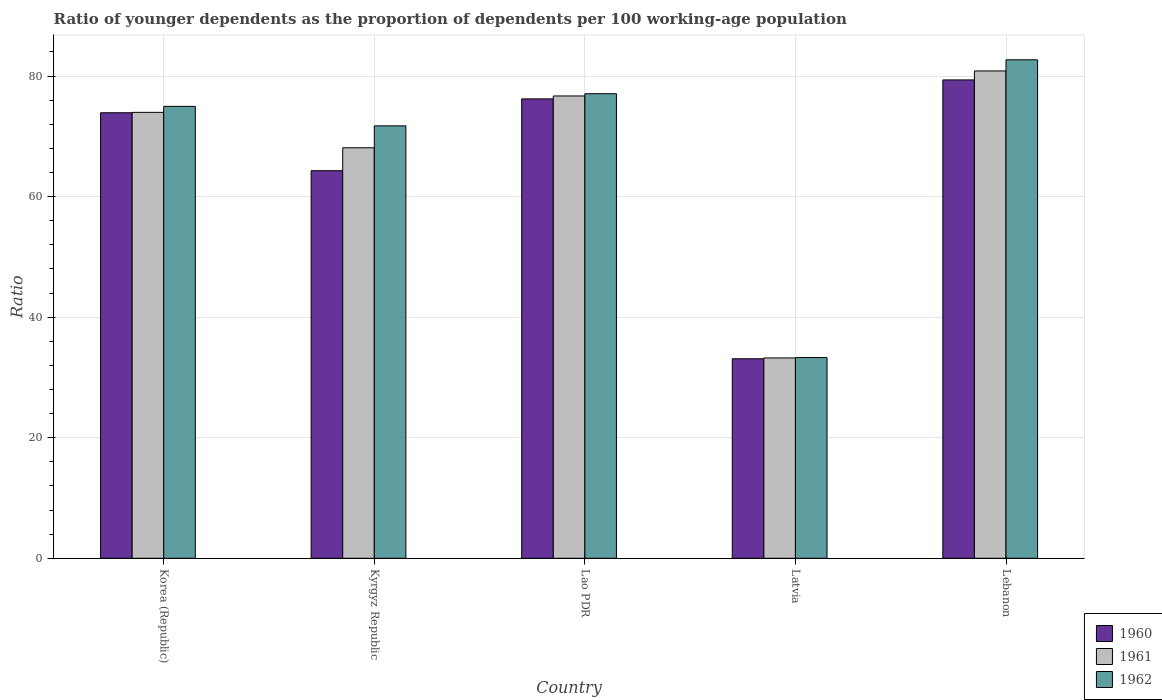Are the number of bars per tick equal to the number of legend labels?
Make the answer very short. Yes. How many bars are there on the 1st tick from the left?
Make the answer very short. 3. How many bars are there on the 3rd tick from the right?
Give a very brief answer. 3. What is the label of the 3rd group of bars from the left?
Provide a short and direct response. Lao PDR. What is the age dependency ratio(young) in 1962 in Kyrgyz Republic?
Your answer should be very brief. 71.73. Across all countries, what is the maximum age dependency ratio(young) in 1961?
Give a very brief answer. 80.84. Across all countries, what is the minimum age dependency ratio(young) in 1961?
Make the answer very short. 33.23. In which country was the age dependency ratio(young) in 1962 maximum?
Your answer should be very brief. Lebanon. In which country was the age dependency ratio(young) in 1962 minimum?
Give a very brief answer. Latvia. What is the total age dependency ratio(young) in 1962 in the graph?
Make the answer very short. 339.74. What is the difference between the age dependency ratio(young) in 1960 in Korea (Republic) and that in Latvia?
Give a very brief answer. 40.81. What is the difference between the age dependency ratio(young) in 1960 in Latvia and the age dependency ratio(young) in 1962 in Kyrgyz Republic?
Your response must be concise. -38.64. What is the average age dependency ratio(young) in 1961 per country?
Provide a succinct answer. 66.56. What is the difference between the age dependency ratio(young) of/in 1961 and age dependency ratio(young) of/in 1962 in Lao PDR?
Your response must be concise. -0.37. In how many countries, is the age dependency ratio(young) in 1962 greater than 60?
Offer a terse response. 4. What is the ratio of the age dependency ratio(young) in 1961 in Latvia to that in Lebanon?
Keep it short and to the point. 0.41. Is the age dependency ratio(young) in 1962 in Korea (Republic) less than that in Lao PDR?
Ensure brevity in your answer.  Yes. Is the difference between the age dependency ratio(young) in 1961 in Kyrgyz Republic and Latvia greater than the difference between the age dependency ratio(young) in 1962 in Kyrgyz Republic and Latvia?
Give a very brief answer. No. What is the difference between the highest and the second highest age dependency ratio(young) in 1960?
Your answer should be very brief. -2.3. What is the difference between the highest and the lowest age dependency ratio(young) in 1962?
Provide a succinct answer. 49.39. Is the sum of the age dependency ratio(young) in 1960 in Kyrgyz Republic and Latvia greater than the maximum age dependency ratio(young) in 1961 across all countries?
Ensure brevity in your answer.  Yes. What does the 2nd bar from the left in Lebanon represents?
Provide a succinct answer. 1961. What does the 3rd bar from the right in Kyrgyz Republic represents?
Ensure brevity in your answer.  1960. How many countries are there in the graph?
Ensure brevity in your answer.  5. What is the difference between two consecutive major ticks on the Y-axis?
Make the answer very short. 20. Are the values on the major ticks of Y-axis written in scientific E-notation?
Your response must be concise. No. Does the graph contain grids?
Keep it short and to the point. Yes. Where does the legend appear in the graph?
Provide a succinct answer. Bottom right. How many legend labels are there?
Your answer should be very brief. 3. How are the legend labels stacked?
Give a very brief answer. Vertical. What is the title of the graph?
Provide a short and direct response. Ratio of younger dependents as the proportion of dependents per 100 working-age population. What is the label or title of the Y-axis?
Give a very brief answer. Ratio. What is the Ratio in 1960 in Korea (Republic)?
Your answer should be very brief. 73.91. What is the Ratio in 1961 in Korea (Republic)?
Keep it short and to the point. 73.97. What is the Ratio in 1962 in Korea (Republic)?
Keep it short and to the point. 74.96. What is the Ratio in 1960 in Kyrgyz Republic?
Give a very brief answer. 64.29. What is the Ratio of 1961 in Kyrgyz Republic?
Your response must be concise. 68.1. What is the Ratio in 1962 in Kyrgyz Republic?
Make the answer very short. 71.73. What is the Ratio in 1960 in Lao PDR?
Make the answer very short. 76.2. What is the Ratio in 1961 in Lao PDR?
Ensure brevity in your answer.  76.69. What is the Ratio of 1962 in Lao PDR?
Keep it short and to the point. 77.06. What is the Ratio of 1960 in Latvia?
Give a very brief answer. 33.09. What is the Ratio of 1961 in Latvia?
Your response must be concise. 33.23. What is the Ratio in 1962 in Latvia?
Make the answer very short. 33.3. What is the Ratio of 1960 in Lebanon?
Provide a succinct answer. 79.35. What is the Ratio of 1961 in Lebanon?
Your answer should be very brief. 80.84. What is the Ratio of 1962 in Lebanon?
Make the answer very short. 82.69. Across all countries, what is the maximum Ratio in 1960?
Offer a terse response. 79.35. Across all countries, what is the maximum Ratio of 1961?
Your answer should be compact. 80.84. Across all countries, what is the maximum Ratio in 1962?
Offer a terse response. 82.69. Across all countries, what is the minimum Ratio in 1960?
Give a very brief answer. 33.09. Across all countries, what is the minimum Ratio of 1961?
Give a very brief answer. 33.23. Across all countries, what is the minimum Ratio in 1962?
Keep it short and to the point. 33.3. What is the total Ratio in 1960 in the graph?
Your answer should be compact. 326.85. What is the total Ratio of 1961 in the graph?
Your answer should be compact. 332.82. What is the total Ratio of 1962 in the graph?
Ensure brevity in your answer.  339.74. What is the difference between the Ratio in 1960 in Korea (Republic) and that in Kyrgyz Republic?
Offer a very short reply. 9.61. What is the difference between the Ratio in 1961 in Korea (Republic) and that in Kyrgyz Republic?
Provide a succinct answer. 5.87. What is the difference between the Ratio in 1962 in Korea (Republic) and that in Kyrgyz Republic?
Make the answer very short. 3.23. What is the difference between the Ratio of 1960 in Korea (Republic) and that in Lao PDR?
Make the answer very short. -2.3. What is the difference between the Ratio in 1961 in Korea (Republic) and that in Lao PDR?
Your response must be concise. -2.72. What is the difference between the Ratio in 1962 in Korea (Republic) and that in Lao PDR?
Keep it short and to the point. -2.1. What is the difference between the Ratio in 1960 in Korea (Republic) and that in Latvia?
Your response must be concise. 40.81. What is the difference between the Ratio of 1961 in Korea (Republic) and that in Latvia?
Give a very brief answer. 40.74. What is the difference between the Ratio of 1962 in Korea (Republic) and that in Latvia?
Your response must be concise. 41.66. What is the difference between the Ratio of 1960 in Korea (Republic) and that in Lebanon?
Your answer should be very brief. -5.45. What is the difference between the Ratio in 1961 in Korea (Republic) and that in Lebanon?
Your response must be concise. -6.87. What is the difference between the Ratio in 1962 in Korea (Republic) and that in Lebanon?
Ensure brevity in your answer.  -7.73. What is the difference between the Ratio in 1960 in Kyrgyz Republic and that in Lao PDR?
Your answer should be very brief. -11.91. What is the difference between the Ratio of 1961 in Kyrgyz Republic and that in Lao PDR?
Your answer should be compact. -8.59. What is the difference between the Ratio of 1962 in Kyrgyz Republic and that in Lao PDR?
Keep it short and to the point. -5.33. What is the difference between the Ratio of 1960 in Kyrgyz Republic and that in Latvia?
Give a very brief answer. 31.2. What is the difference between the Ratio in 1961 in Kyrgyz Republic and that in Latvia?
Provide a short and direct response. 34.87. What is the difference between the Ratio in 1962 in Kyrgyz Republic and that in Latvia?
Make the answer very short. 38.43. What is the difference between the Ratio of 1960 in Kyrgyz Republic and that in Lebanon?
Your response must be concise. -15.06. What is the difference between the Ratio of 1961 in Kyrgyz Republic and that in Lebanon?
Keep it short and to the point. -12.74. What is the difference between the Ratio of 1962 in Kyrgyz Republic and that in Lebanon?
Ensure brevity in your answer.  -10.96. What is the difference between the Ratio of 1960 in Lao PDR and that in Latvia?
Keep it short and to the point. 43.11. What is the difference between the Ratio in 1961 in Lao PDR and that in Latvia?
Keep it short and to the point. 43.46. What is the difference between the Ratio in 1962 in Lao PDR and that in Latvia?
Offer a very short reply. 43.76. What is the difference between the Ratio of 1960 in Lao PDR and that in Lebanon?
Keep it short and to the point. -3.15. What is the difference between the Ratio of 1961 in Lao PDR and that in Lebanon?
Your response must be concise. -4.15. What is the difference between the Ratio in 1962 in Lao PDR and that in Lebanon?
Give a very brief answer. -5.63. What is the difference between the Ratio in 1960 in Latvia and that in Lebanon?
Your answer should be very brief. -46.26. What is the difference between the Ratio of 1961 in Latvia and that in Lebanon?
Provide a short and direct response. -47.61. What is the difference between the Ratio in 1962 in Latvia and that in Lebanon?
Offer a very short reply. -49.39. What is the difference between the Ratio of 1960 in Korea (Republic) and the Ratio of 1961 in Kyrgyz Republic?
Your response must be concise. 5.81. What is the difference between the Ratio of 1960 in Korea (Republic) and the Ratio of 1962 in Kyrgyz Republic?
Your response must be concise. 2.17. What is the difference between the Ratio in 1961 in Korea (Republic) and the Ratio in 1962 in Kyrgyz Republic?
Make the answer very short. 2.24. What is the difference between the Ratio in 1960 in Korea (Republic) and the Ratio in 1961 in Lao PDR?
Provide a succinct answer. -2.78. What is the difference between the Ratio in 1960 in Korea (Republic) and the Ratio in 1962 in Lao PDR?
Keep it short and to the point. -3.16. What is the difference between the Ratio in 1961 in Korea (Republic) and the Ratio in 1962 in Lao PDR?
Make the answer very short. -3.09. What is the difference between the Ratio in 1960 in Korea (Republic) and the Ratio in 1961 in Latvia?
Offer a very short reply. 40.68. What is the difference between the Ratio of 1960 in Korea (Republic) and the Ratio of 1962 in Latvia?
Offer a terse response. 40.61. What is the difference between the Ratio in 1961 in Korea (Republic) and the Ratio in 1962 in Latvia?
Keep it short and to the point. 40.67. What is the difference between the Ratio of 1960 in Korea (Republic) and the Ratio of 1961 in Lebanon?
Your answer should be compact. -6.93. What is the difference between the Ratio in 1960 in Korea (Republic) and the Ratio in 1962 in Lebanon?
Offer a terse response. -8.78. What is the difference between the Ratio of 1961 in Korea (Republic) and the Ratio of 1962 in Lebanon?
Your answer should be very brief. -8.72. What is the difference between the Ratio of 1960 in Kyrgyz Republic and the Ratio of 1961 in Lao PDR?
Keep it short and to the point. -12.4. What is the difference between the Ratio of 1960 in Kyrgyz Republic and the Ratio of 1962 in Lao PDR?
Your answer should be compact. -12.77. What is the difference between the Ratio of 1961 in Kyrgyz Republic and the Ratio of 1962 in Lao PDR?
Provide a short and direct response. -8.97. What is the difference between the Ratio of 1960 in Kyrgyz Republic and the Ratio of 1961 in Latvia?
Make the answer very short. 31.06. What is the difference between the Ratio of 1960 in Kyrgyz Republic and the Ratio of 1962 in Latvia?
Provide a short and direct response. 30.99. What is the difference between the Ratio of 1961 in Kyrgyz Republic and the Ratio of 1962 in Latvia?
Your answer should be very brief. 34.8. What is the difference between the Ratio in 1960 in Kyrgyz Republic and the Ratio in 1961 in Lebanon?
Your answer should be compact. -16.55. What is the difference between the Ratio of 1960 in Kyrgyz Republic and the Ratio of 1962 in Lebanon?
Give a very brief answer. -18.4. What is the difference between the Ratio of 1961 in Kyrgyz Republic and the Ratio of 1962 in Lebanon?
Your answer should be very brief. -14.59. What is the difference between the Ratio in 1960 in Lao PDR and the Ratio in 1961 in Latvia?
Your answer should be very brief. 42.97. What is the difference between the Ratio in 1960 in Lao PDR and the Ratio in 1962 in Latvia?
Ensure brevity in your answer.  42.91. What is the difference between the Ratio in 1961 in Lao PDR and the Ratio in 1962 in Latvia?
Offer a terse response. 43.39. What is the difference between the Ratio in 1960 in Lao PDR and the Ratio in 1961 in Lebanon?
Your answer should be compact. -4.63. What is the difference between the Ratio of 1960 in Lao PDR and the Ratio of 1962 in Lebanon?
Provide a succinct answer. -6.48. What is the difference between the Ratio in 1961 in Lao PDR and the Ratio in 1962 in Lebanon?
Give a very brief answer. -6. What is the difference between the Ratio in 1960 in Latvia and the Ratio in 1961 in Lebanon?
Keep it short and to the point. -47.74. What is the difference between the Ratio of 1960 in Latvia and the Ratio of 1962 in Lebanon?
Provide a succinct answer. -49.59. What is the difference between the Ratio of 1961 in Latvia and the Ratio of 1962 in Lebanon?
Ensure brevity in your answer.  -49.46. What is the average Ratio in 1960 per country?
Ensure brevity in your answer.  65.37. What is the average Ratio in 1961 per country?
Make the answer very short. 66.56. What is the average Ratio of 1962 per country?
Provide a short and direct response. 67.95. What is the difference between the Ratio in 1960 and Ratio in 1961 in Korea (Republic)?
Offer a very short reply. -0.06. What is the difference between the Ratio of 1960 and Ratio of 1962 in Korea (Republic)?
Give a very brief answer. -1.05. What is the difference between the Ratio in 1961 and Ratio in 1962 in Korea (Republic)?
Keep it short and to the point. -0.99. What is the difference between the Ratio of 1960 and Ratio of 1961 in Kyrgyz Republic?
Ensure brevity in your answer.  -3.8. What is the difference between the Ratio of 1960 and Ratio of 1962 in Kyrgyz Republic?
Your response must be concise. -7.44. What is the difference between the Ratio in 1961 and Ratio in 1962 in Kyrgyz Republic?
Provide a short and direct response. -3.64. What is the difference between the Ratio in 1960 and Ratio in 1961 in Lao PDR?
Your answer should be compact. -0.48. What is the difference between the Ratio in 1960 and Ratio in 1962 in Lao PDR?
Ensure brevity in your answer.  -0.86. What is the difference between the Ratio in 1961 and Ratio in 1962 in Lao PDR?
Offer a terse response. -0.37. What is the difference between the Ratio in 1960 and Ratio in 1961 in Latvia?
Your response must be concise. -0.13. What is the difference between the Ratio of 1960 and Ratio of 1962 in Latvia?
Your answer should be very brief. -0.2. What is the difference between the Ratio in 1961 and Ratio in 1962 in Latvia?
Offer a very short reply. -0.07. What is the difference between the Ratio of 1960 and Ratio of 1961 in Lebanon?
Offer a very short reply. -1.49. What is the difference between the Ratio in 1960 and Ratio in 1962 in Lebanon?
Offer a very short reply. -3.34. What is the difference between the Ratio of 1961 and Ratio of 1962 in Lebanon?
Offer a terse response. -1.85. What is the ratio of the Ratio of 1960 in Korea (Republic) to that in Kyrgyz Republic?
Your answer should be compact. 1.15. What is the ratio of the Ratio in 1961 in Korea (Republic) to that in Kyrgyz Republic?
Make the answer very short. 1.09. What is the ratio of the Ratio in 1962 in Korea (Republic) to that in Kyrgyz Republic?
Ensure brevity in your answer.  1.04. What is the ratio of the Ratio of 1960 in Korea (Republic) to that in Lao PDR?
Your answer should be compact. 0.97. What is the ratio of the Ratio of 1961 in Korea (Republic) to that in Lao PDR?
Keep it short and to the point. 0.96. What is the ratio of the Ratio in 1962 in Korea (Republic) to that in Lao PDR?
Your answer should be compact. 0.97. What is the ratio of the Ratio in 1960 in Korea (Republic) to that in Latvia?
Your answer should be very brief. 2.23. What is the ratio of the Ratio of 1961 in Korea (Republic) to that in Latvia?
Your answer should be very brief. 2.23. What is the ratio of the Ratio of 1962 in Korea (Republic) to that in Latvia?
Ensure brevity in your answer.  2.25. What is the ratio of the Ratio in 1960 in Korea (Republic) to that in Lebanon?
Your answer should be very brief. 0.93. What is the ratio of the Ratio in 1961 in Korea (Republic) to that in Lebanon?
Your answer should be compact. 0.92. What is the ratio of the Ratio of 1962 in Korea (Republic) to that in Lebanon?
Give a very brief answer. 0.91. What is the ratio of the Ratio of 1960 in Kyrgyz Republic to that in Lao PDR?
Give a very brief answer. 0.84. What is the ratio of the Ratio in 1961 in Kyrgyz Republic to that in Lao PDR?
Ensure brevity in your answer.  0.89. What is the ratio of the Ratio in 1962 in Kyrgyz Republic to that in Lao PDR?
Make the answer very short. 0.93. What is the ratio of the Ratio in 1960 in Kyrgyz Republic to that in Latvia?
Make the answer very short. 1.94. What is the ratio of the Ratio in 1961 in Kyrgyz Republic to that in Latvia?
Your answer should be compact. 2.05. What is the ratio of the Ratio in 1962 in Kyrgyz Republic to that in Latvia?
Your answer should be very brief. 2.15. What is the ratio of the Ratio of 1960 in Kyrgyz Republic to that in Lebanon?
Offer a very short reply. 0.81. What is the ratio of the Ratio in 1961 in Kyrgyz Republic to that in Lebanon?
Keep it short and to the point. 0.84. What is the ratio of the Ratio in 1962 in Kyrgyz Republic to that in Lebanon?
Offer a very short reply. 0.87. What is the ratio of the Ratio in 1960 in Lao PDR to that in Latvia?
Your answer should be compact. 2.3. What is the ratio of the Ratio of 1961 in Lao PDR to that in Latvia?
Your answer should be compact. 2.31. What is the ratio of the Ratio of 1962 in Lao PDR to that in Latvia?
Provide a short and direct response. 2.31. What is the ratio of the Ratio in 1960 in Lao PDR to that in Lebanon?
Provide a short and direct response. 0.96. What is the ratio of the Ratio of 1961 in Lao PDR to that in Lebanon?
Ensure brevity in your answer.  0.95. What is the ratio of the Ratio of 1962 in Lao PDR to that in Lebanon?
Provide a short and direct response. 0.93. What is the ratio of the Ratio in 1960 in Latvia to that in Lebanon?
Ensure brevity in your answer.  0.42. What is the ratio of the Ratio of 1961 in Latvia to that in Lebanon?
Offer a very short reply. 0.41. What is the ratio of the Ratio of 1962 in Latvia to that in Lebanon?
Provide a succinct answer. 0.4. What is the difference between the highest and the second highest Ratio of 1960?
Offer a terse response. 3.15. What is the difference between the highest and the second highest Ratio of 1961?
Offer a very short reply. 4.15. What is the difference between the highest and the second highest Ratio in 1962?
Make the answer very short. 5.63. What is the difference between the highest and the lowest Ratio of 1960?
Ensure brevity in your answer.  46.26. What is the difference between the highest and the lowest Ratio of 1961?
Provide a short and direct response. 47.61. What is the difference between the highest and the lowest Ratio of 1962?
Provide a short and direct response. 49.39. 